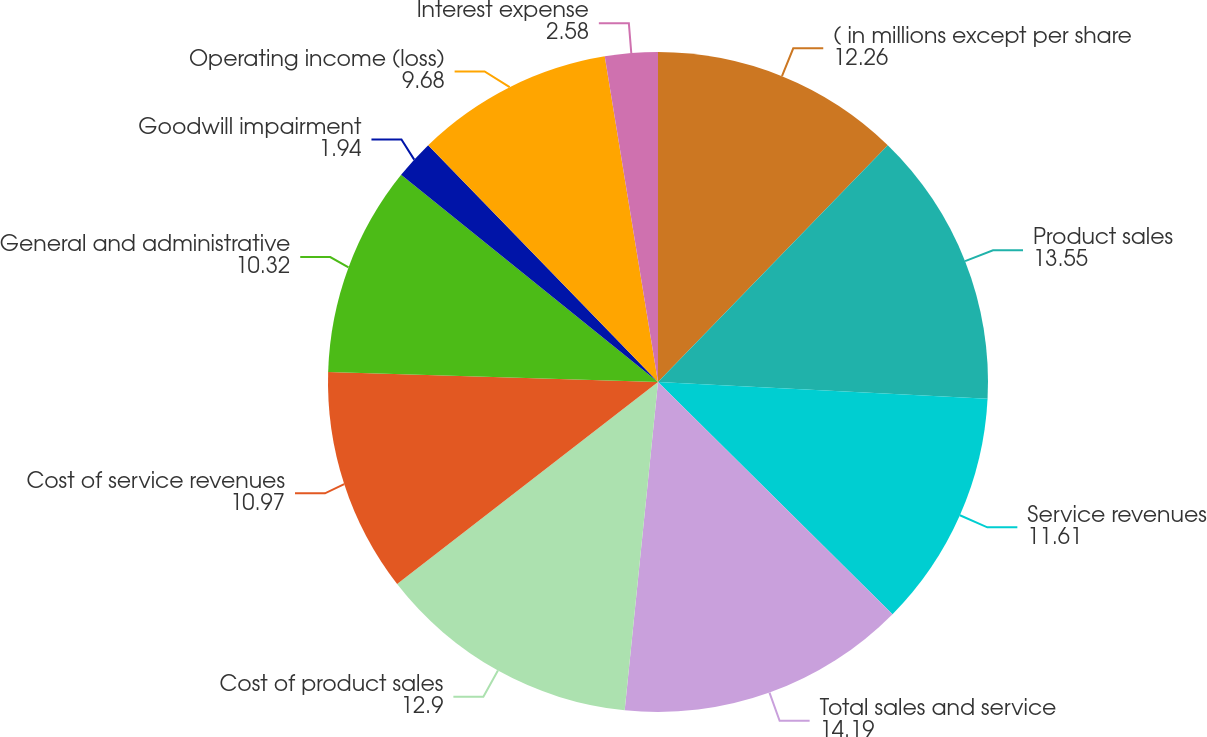Convert chart. <chart><loc_0><loc_0><loc_500><loc_500><pie_chart><fcel>( in millions except per share<fcel>Product sales<fcel>Service revenues<fcel>Total sales and service<fcel>Cost of product sales<fcel>Cost of service revenues<fcel>General and administrative<fcel>Goodwill impairment<fcel>Operating income (loss)<fcel>Interest expense<nl><fcel>12.26%<fcel>13.55%<fcel>11.61%<fcel>14.19%<fcel>12.9%<fcel>10.97%<fcel>10.32%<fcel>1.94%<fcel>9.68%<fcel>2.58%<nl></chart> 